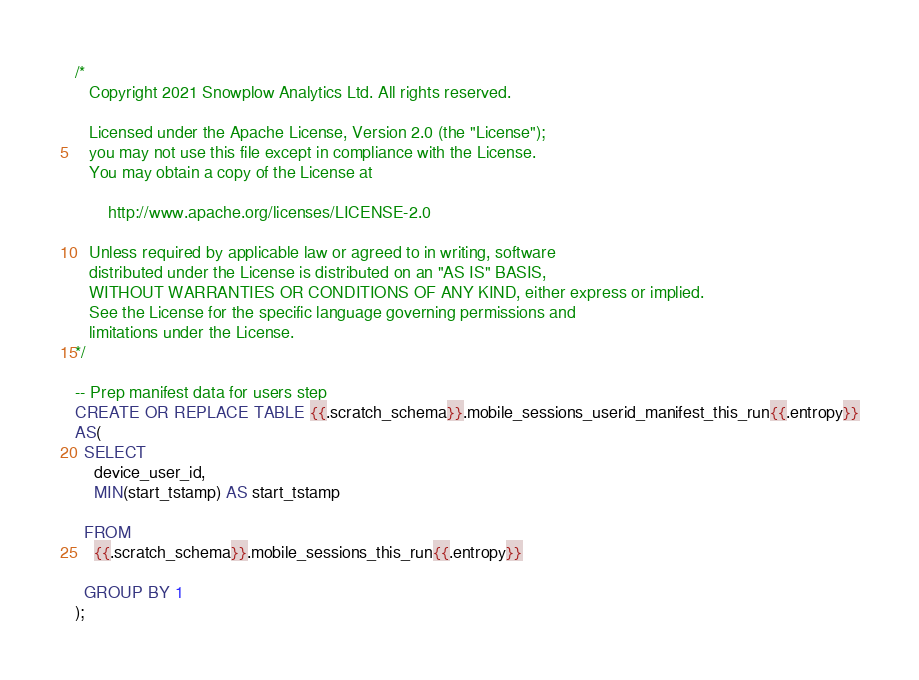Convert code to text. <code><loc_0><loc_0><loc_500><loc_500><_SQL_>/*
   Copyright 2021 Snowplow Analytics Ltd. All rights reserved.

   Licensed under the Apache License, Version 2.0 (the "License");
   you may not use this file except in compliance with the License.
   You may obtain a copy of the License at

       http://www.apache.org/licenses/LICENSE-2.0

   Unless required by applicable law or agreed to in writing, software
   distributed under the License is distributed on an "AS IS" BASIS,
   WITHOUT WARRANTIES OR CONDITIONS OF ANY KIND, either express or implied.
   See the License for the specific language governing permissions and
   limitations under the License.
*/

-- Prep manifest data for users step
CREATE OR REPLACE TABLE {{.scratch_schema}}.mobile_sessions_userid_manifest_this_run{{.entropy}}
AS(
  SELECT
    device_user_id,
    MIN(start_tstamp) AS start_tstamp

  FROM
    {{.scratch_schema}}.mobile_sessions_this_run{{.entropy}}

  GROUP BY 1
);
</code> 